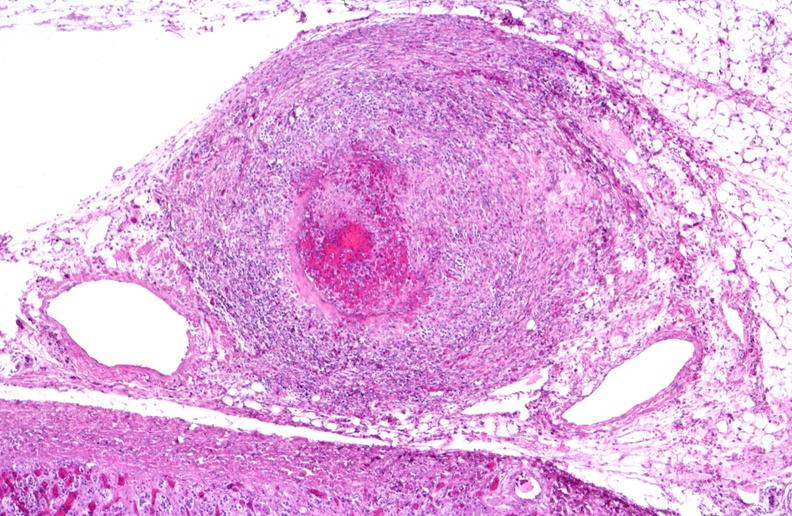s all the fat necrosis present?
Answer the question using a single word or phrase. No 